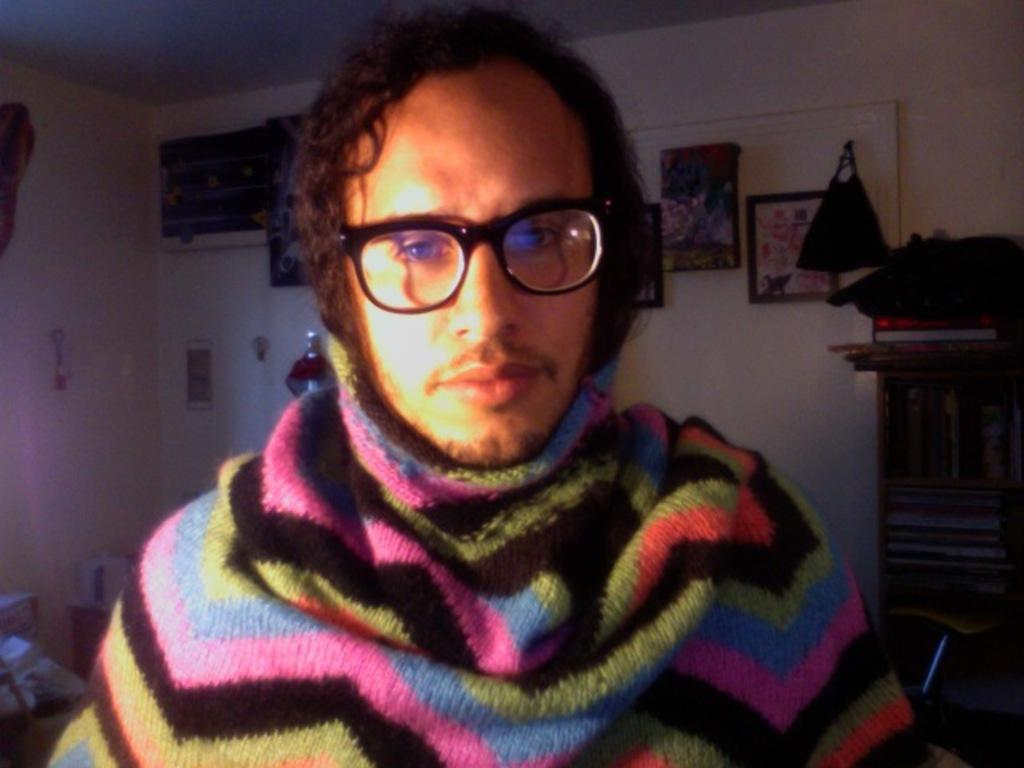What is the person in the image wearing? The person in the image is wearing spectacles. What can be seen in the background of the image? There are frames, posters, and a bag on the wall in the background of the image. What type of objects are on the wall? The objects on the wall are frames, posters, and a bag. What is located near the wall in the image? There are books in a rack in the image. Are there any other objects visible in the image? Yes, there are other objects visible in the image. What number is written on the form in the image? There is no form present in the image, so it is not possible to determine if a number is written on it. 